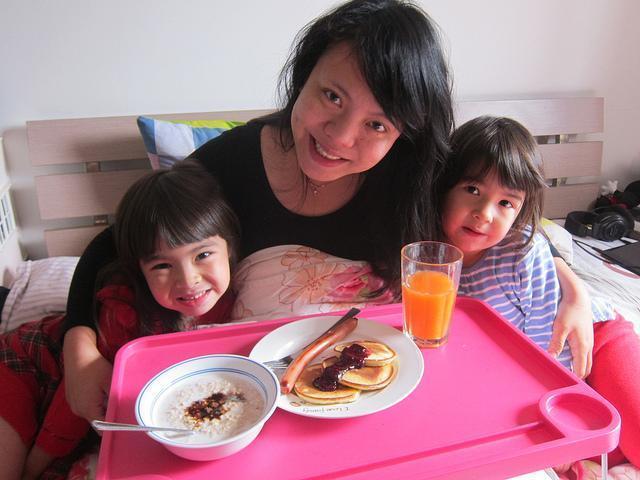How many people can you see?
Give a very brief answer. 3. 